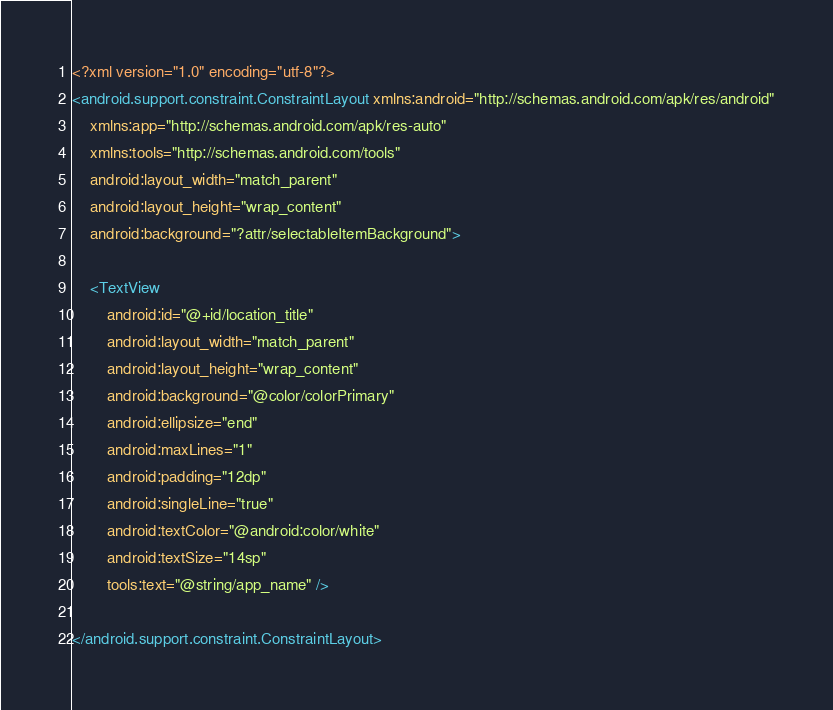<code> <loc_0><loc_0><loc_500><loc_500><_XML_><?xml version="1.0" encoding="utf-8"?>
<android.support.constraint.ConstraintLayout xmlns:android="http://schemas.android.com/apk/res/android"
    xmlns:app="http://schemas.android.com/apk/res-auto"
    xmlns:tools="http://schemas.android.com/tools"
    android:layout_width="match_parent"
    android:layout_height="wrap_content"
    android:background="?attr/selectableItemBackground">

    <TextView
        android:id="@+id/location_title"
        android:layout_width="match_parent"
        android:layout_height="wrap_content"
        android:background="@color/colorPrimary"
        android:ellipsize="end"
        android:maxLines="1"
        android:padding="12dp"
        android:singleLine="true"
        android:textColor="@android:color/white"
        android:textSize="14sp"
        tools:text="@string/app_name" />

</android.support.constraint.ConstraintLayout></code> 